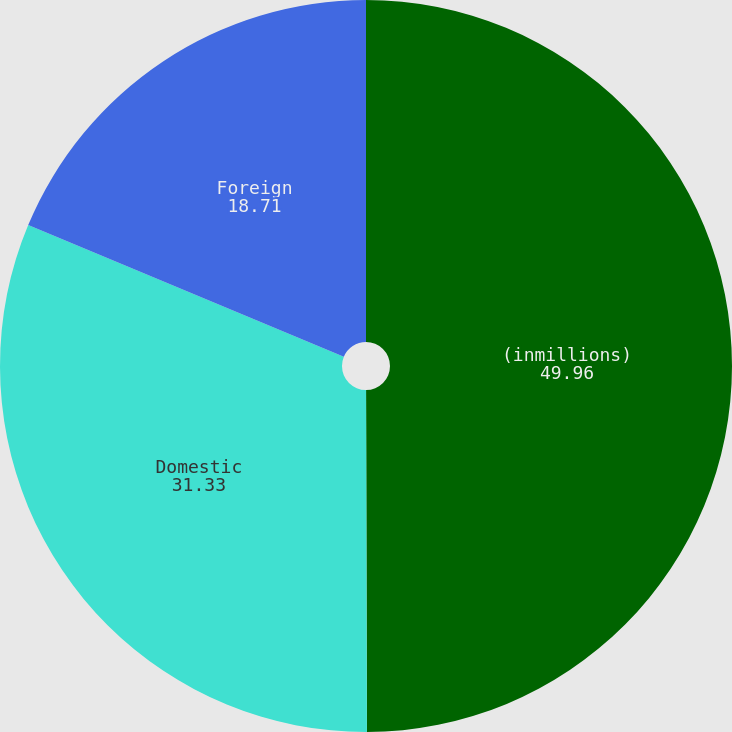Convert chart to OTSL. <chart><loc_0><loc_0><loc_500><loc_500><pie_chart><fcel>(inmillions)<fcel>Domestic<fcel>Foreign<nl><fcel>49.96%<fcel>31.33%<fcel>18.71%<nl></chart> 